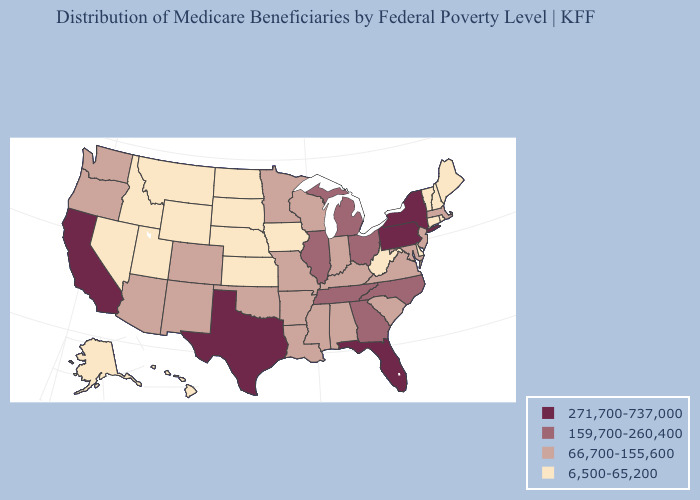Does the map have missing data?
Quick response, please. No. Name the states that have a value in the range 271,700-737,000?
Keep it brief. California, Florida, New York, Pennsylvania, Texas. Name the states that have a value in the range 159,700-260,400?
Quick response, please. Georgia, Illinois, Michigan, North Carolina, Ohio, Tennessee. What is the value of Alabama?
Answer briefly. 66,700-155,600. Does New Mexico have the same value as Arkansas?
Keep it brief. Yes. What is the lowest value in the South?
Quick response, please. 6,500-65,200. Name the states that have a value in the range 271,700-737,000?
Concise answer only. California, Florida, New York, Pennsylvania, Texas. What is the value of Wisconsin?
Be succinct. 66,700-155,600. What is the highest value in the USA?
Concise answer only. 271,700-737,000. What is the highest value in the USA?
Concise answer only. 271,700-737,000. Name the states that have a value in the range 66,700-155,600?
Write a very short answer. Alabama, Arizona, Arkansas, Colorado, Indiana, Kentucky, Louisiana, Maryland, Massachusetts, Minnesota, Mississippi, Missouri, New Jersey, New Mexico, Oklahoma, Oregon, South Carolina, Virginia, Washington, Wisconsin. How many symbols are there in the legend?
Quick response, please. 4. Does Tennessee have the same value as North Carolina?
Short answer required. Yes. Among the states that border South Dakota , does North Dakota have the highest value?
Quick response, please. No. Which states have the lowest value in the USA?
Keep it brief. Alaska, Connecticut, Delaware, Hawaii, Idaho, Iowa, Kansas, Maine, Montana, Nebraska, Nevada, New Hampshire, North Dakota, Rhode Island, South Dakota, Utah, Vermont, West Virginia, Wyoming. 